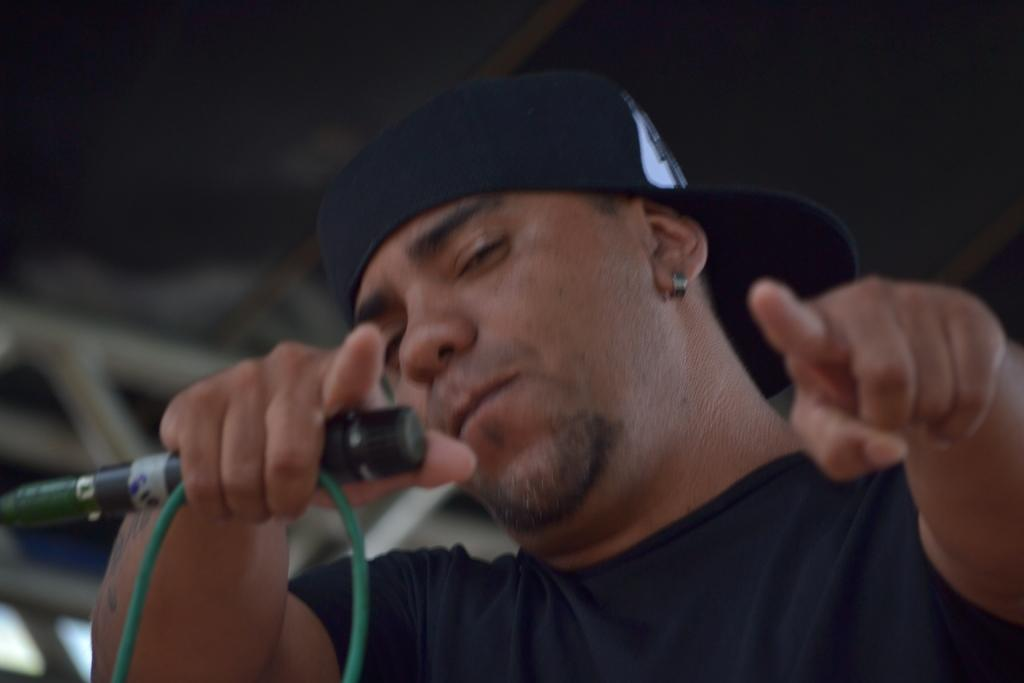What is the main subject of the image? The main subject of the image is a man. What is the man wearing in the image? The man is wearing a black t-shirt in the image. What accessory is the man wearing in the image? The man is wearing a cap in the image. What object is the man holding in the image? The man is holding a mic in the image. Can you tell me how many kittens are participating in the competition in the image? There are no kittens or competition present in the image. What type of stretch is the man performing in the image? There is no stretch being performed by the man in the image. 